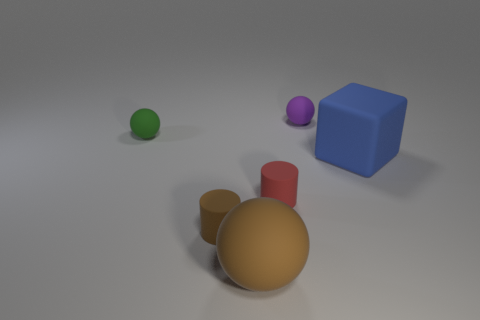If I wanted to create a similar setup at home, what kind of objects and colors should I use to achieve this? To recreate this setup, you would need objects of simple geometric shapes: a cube, a couple of spheres, and cylinders. You should look for or paint these objects in solid, matte colors, specifically gold, red, blue, green, and purple. Arrange them on a smooth, flat surface under a well-diffused, overhead light to achieve a similar shadow effect. Preferably, choose a neutral background like the light grey shown in the image to ensure the colors of the objects stand out. 